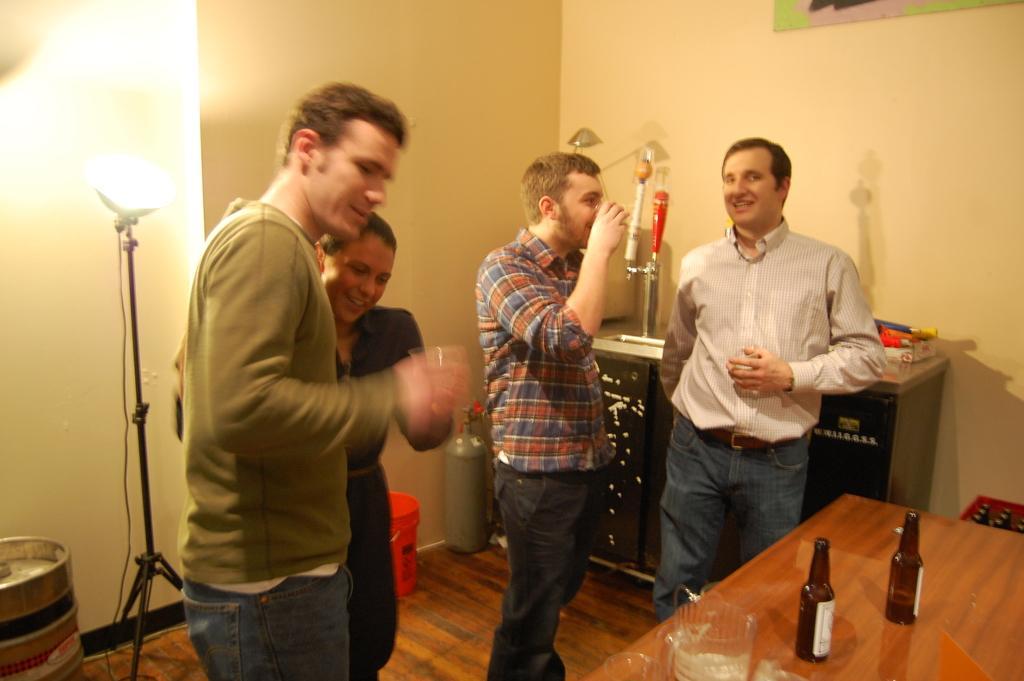Describe this image in one or two sentences. In this picture there are four people standing. Some of them were drinking. There is a woman among them. There is a table on which some bottles and glass was placed. In the background there is a table and a wall here. We can observe a light too. 